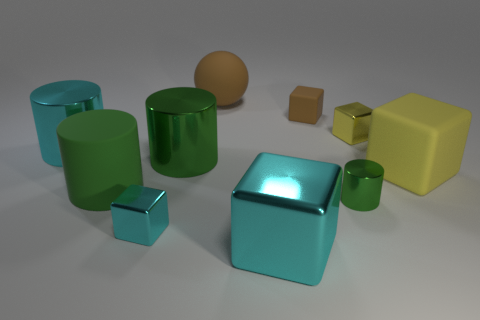Does the tiny yellow thing have the same shape as the large brown matte object? The small yellow object, which appears to be a cube, does not have the same shape as the large brown object, which looks like a sphere. The cube has six faces with edges of equal length, while the sphere has a continuous curved surface without edges or vertices. 